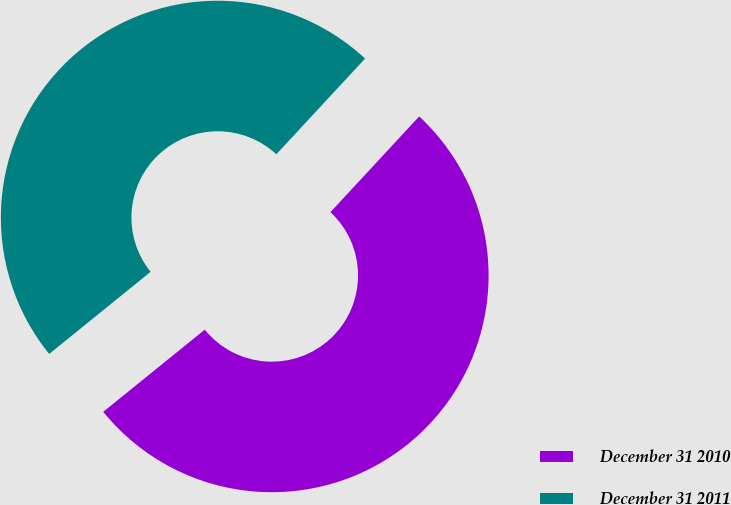Convert chart to OTSL. <chart><loc_0><loc_0><loc_500><loc_500><pie_chart><fcel>December 31 2010<fcel>December 31 2011<nl><fcel>52.27%<fcel>47.73%<nl></chart> 